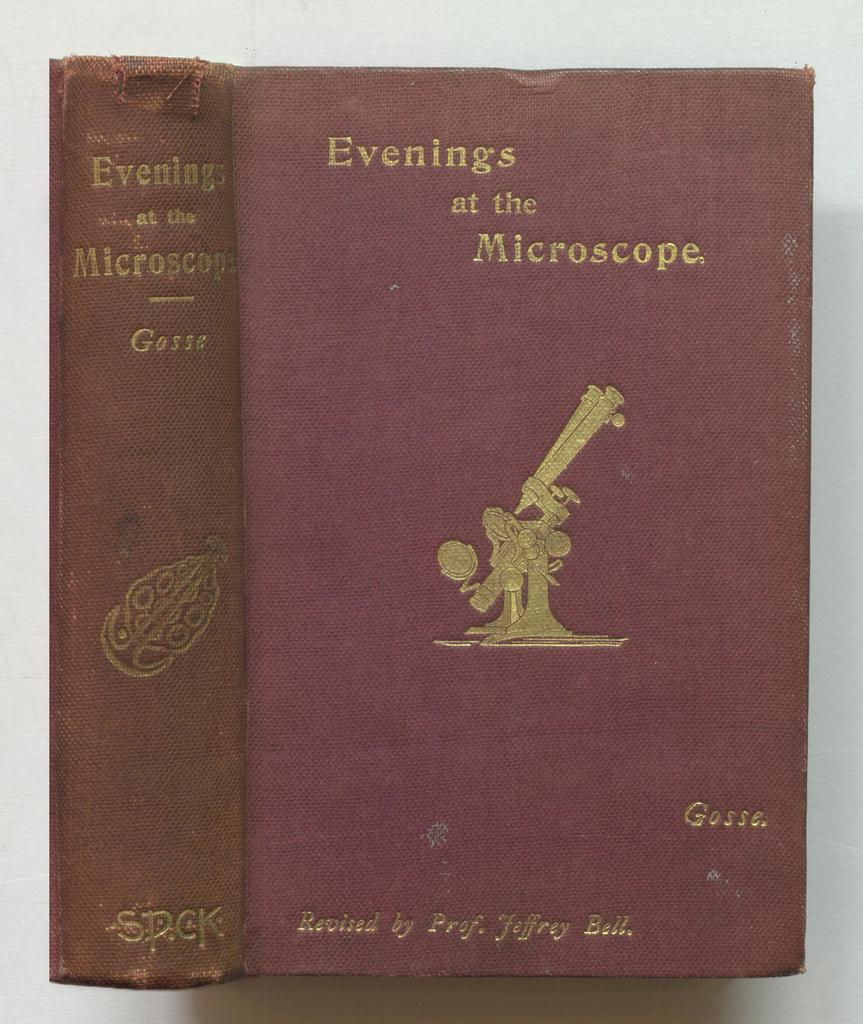What object is present in the image that is typically used for reading? There is a book in the image. What can be seen on the book's cover? The book has an image on it. What else is featured on the book besides the image? The book has text on it. What is the color of the background in the image? The background of the image is white in color. What type of instrument is being played by the person in the image? There is no person or instrument present in the image; it only features a book with an image and text on it. Can you tell me about the relation between the two individuals in the image? There are no individuals present in the image, so it is not possible to discuss any relations between them. 